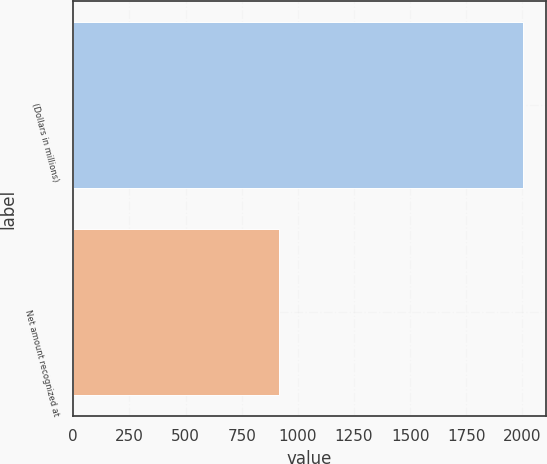<chart> <loc_0><loc_0><loc_500><loc_500><bar_chart><fcel>(Dollars in millions)<fcel>Net amount recognized at<nl><fcel>2004<fcel>918<nl></chart> 